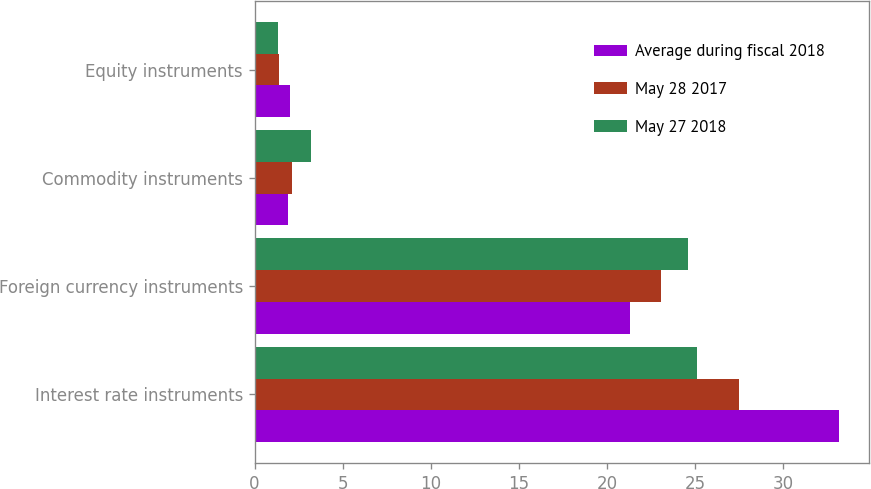<chart> <loc_0><loc_0><loc_500><loc_500><stacked_bar_chart><ecel><fcel>Interest rate instruments<fcel>Foreign currency instruments<fcel>Commodity instruments<fcel>Equity instruments<nl><fcel>Average during fiscal 2018<fcel>33.2<fcel>21.3<fcel>1.9<fcel>2<nl><fcel>May 28 2017<fcel>27.5<fcel>23.1<fcel>2.1<fcel>1.4<nl><fcel>May 27 2018<fcel>25.1<fcel>24.6<fcel>3.2<fcel>1.3<nl></chart> 